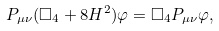<formula> <loc_0><loc_0><loc_500><loc_500>P _ { \mu \nu } ( \square _ { 4 } + 8 H ^ { 2 } ) \varphi = \square _ { 4 } P _ { \mu \nu } \varphi ,</formula> 